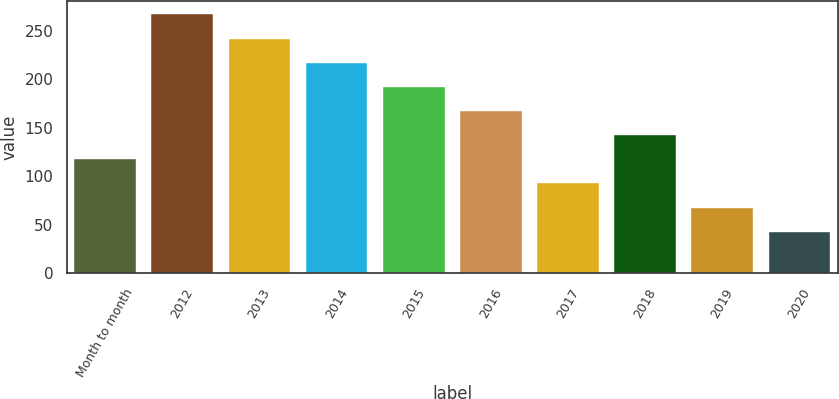<chart> <loc_0><loc_0><loc_500><loc_500><bar_chart><fcel>Month to month<fcel>2012<fcel>2013<fcel>2014<fcel>2015<fcel>2016<fcel>2017<fcel>2018<fcel>2019<fcel>2020<nl><fcel>117.6<fcel>267<fcel>242.1<fcel>217.2<fcel>192.3<fcel>167.4<fcel>92.7<fcel>142.5<fcel>67.8<fcel>42.9<nl></chart> 